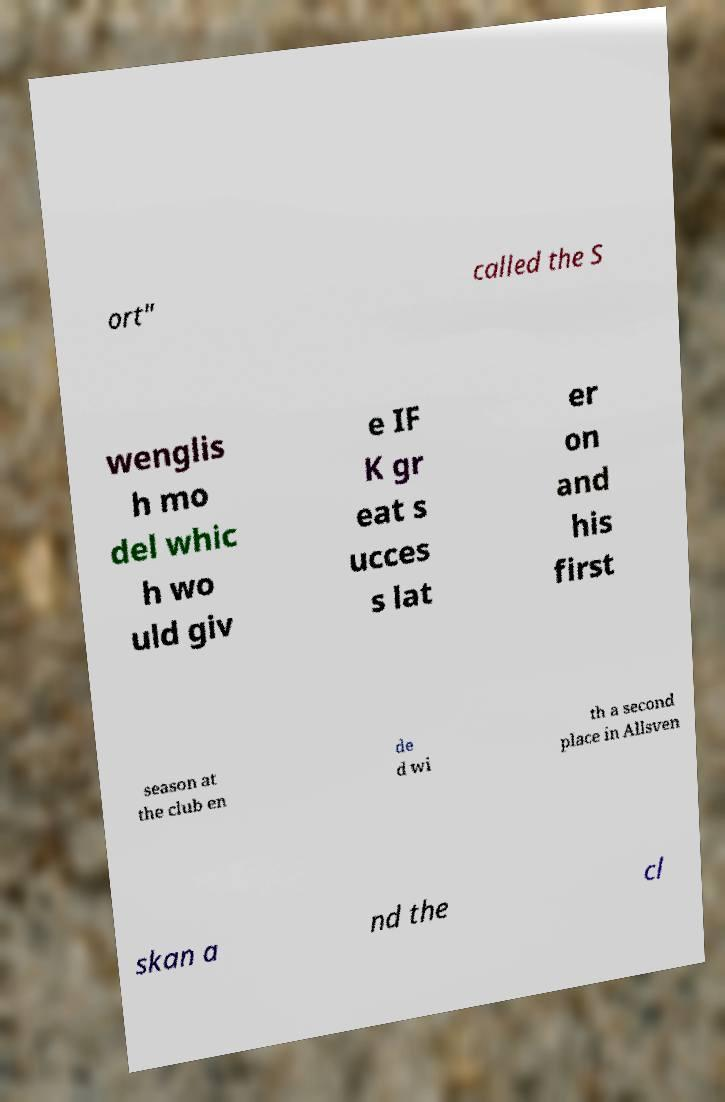Can you accurately transcribe the text from the provided image for me? ort" called the S wenglis h mo del whic h wo uld giv e IF K gr eat s ucces s lat er on and his first season at the club en de d wi th a second place in Allsven skan a nd the cl 